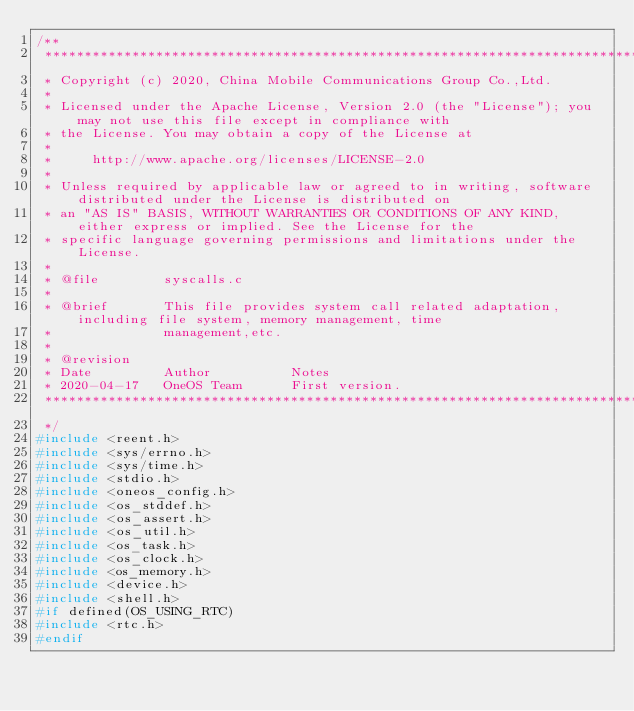Convert code to text. <code><loc_0><loc_0><loc_500><loc_500><_C_>/**
 ***********************************************************************************************************************
 * Copyright (c) 2020, China Mobile Communications Group Co.,Ltd.
 *
 * Licensed under the Apache License, Version 2.0 (the "License"); you may not use this file except in compliance with 
 * the License. You may obtain a copy of the License at
 *
 *     http://www.apache.org/licenses/LICENSE-2.0
 *
 * Unless required by applicable law or agreed to in writing, software distributed under the License is distributed on 
 * an "AS IS" BASIS, WITHOUT WARRANTIES OR CONDITIONS OF ANY KIND, either express or implied. See the License for the 
 * specific language governing permissions and limitations under the License.
 *
 * @file        syscalls.c
 *
 * @brief       This file provides system call related adaptation, including file system, memory management, time 
 *              management,etc.
 *
 * @revision
 * Date         Author          Notes
 * 2020-04-17   OneOS Team      First version.
 ***********************************************************************************************************************
 */
#include <reent.h>
#include <sys/errno.h>
#include <sys/time.h>
#include <stdio.h>
#include <oneos_config.h>
#include <os_stddef.h>
#include <os_assert.h>
#include <os_util.h>
#include <os_task.h>
#include <os_clock.h>
#include <os_memory.h>
#include <device.h>
#include <shell.h>
#if defined(OS_USING_RTC)
#include <rtc.h>
#endif
</code> 